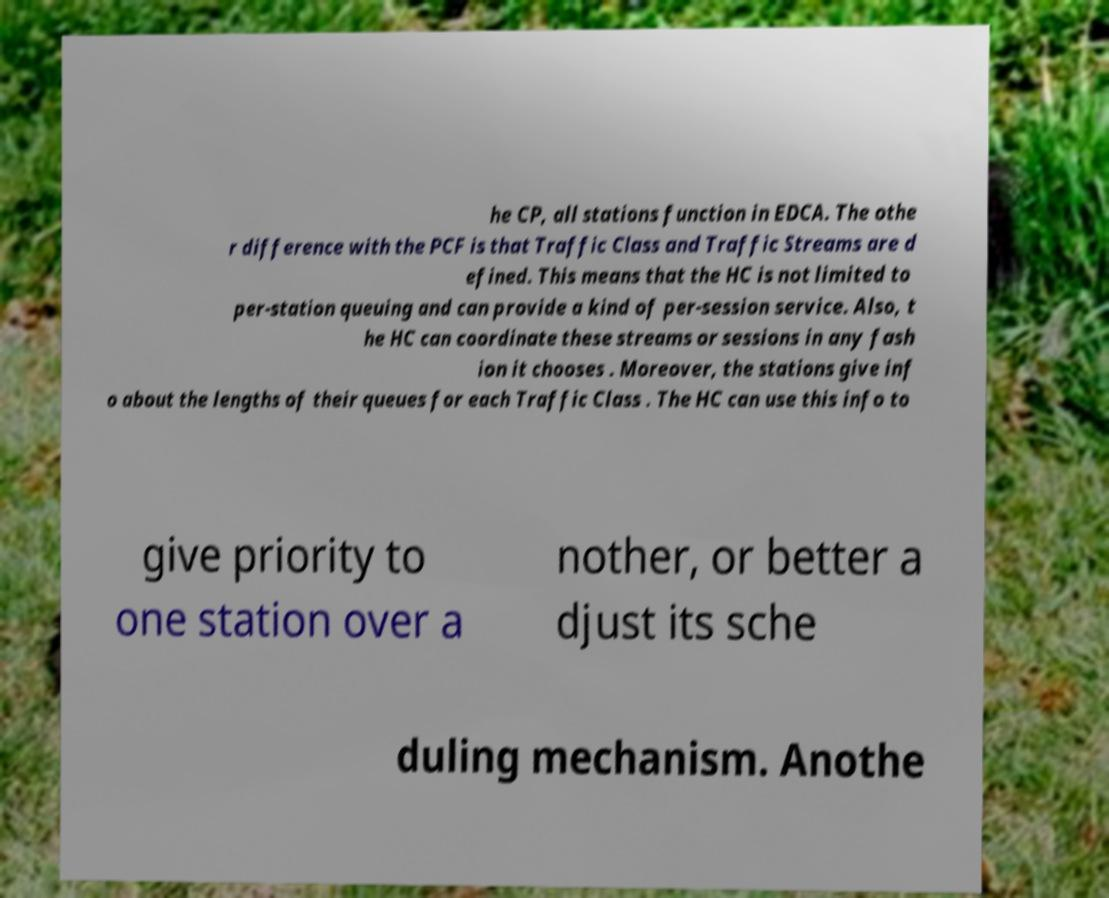Could you assist in decoding the text presented in this image and type it out clearly? he CP, all stations function in EDCA. The othe r difference with the PCF is that Traffic Class and Traffic Streams are d efined. This means that the HC is not limited to per-station queuing and can provide a kind of per-session service. Also, t he HC can coordinate these streams or sessions in any fash ion it chooses . Moreover, the stations give inf o about the lengths of their queues for each Traffic Class . The HC can use this info to give priority to one station over a nother, or better a djust its sche duling mechanism. Anothe 